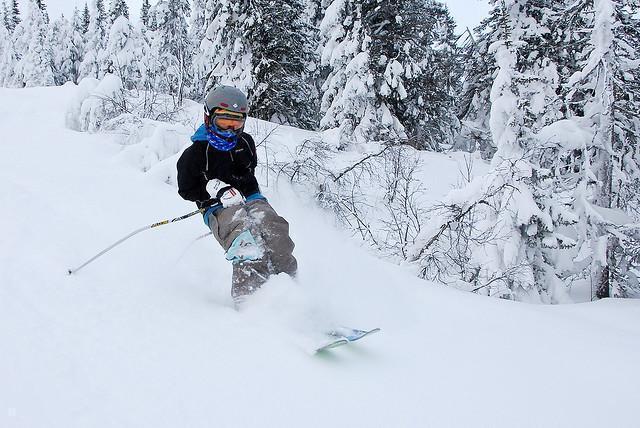Where might this child be located?
Select the accurate answer and provide explanation: 'Answer: answer
Rationale: rationale.'
Options: Texas, california, florida, colorado. Answer: colorado.
Rationale: The child is skiing in an area that is blanketed by snow. florida, texas, and most of california are too warm to get significant amounts of snow. 